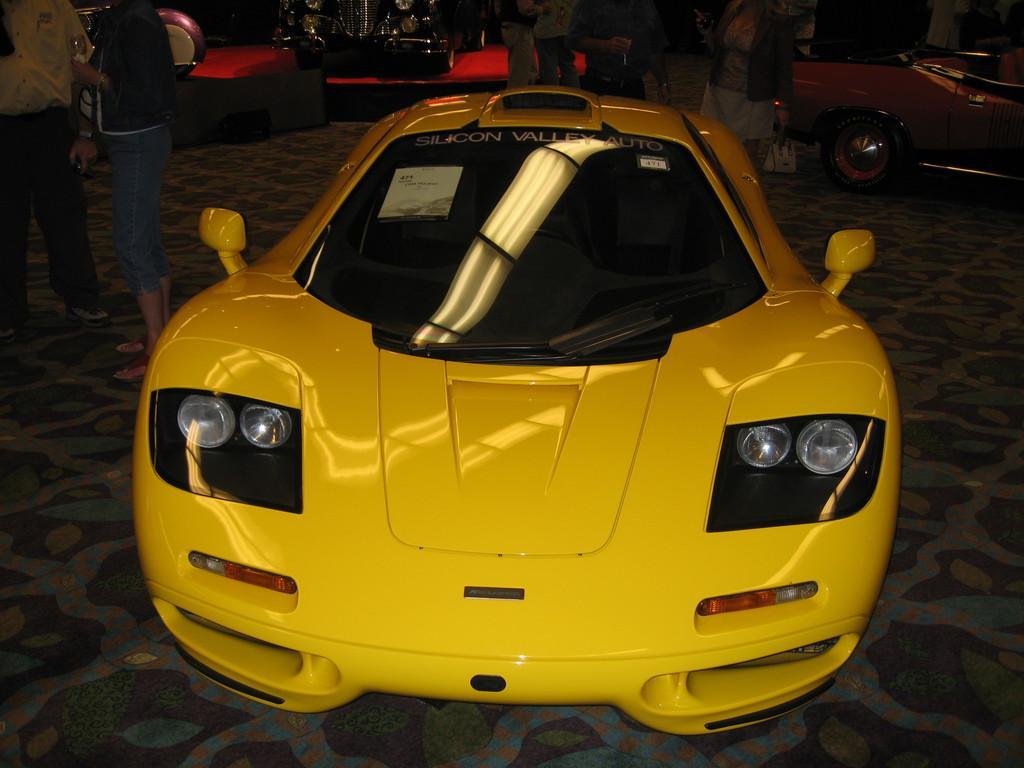Can you describe this image briefly? In this image we can see few vehicles and people holding the objects, in the background, we can see there are some other objects. 